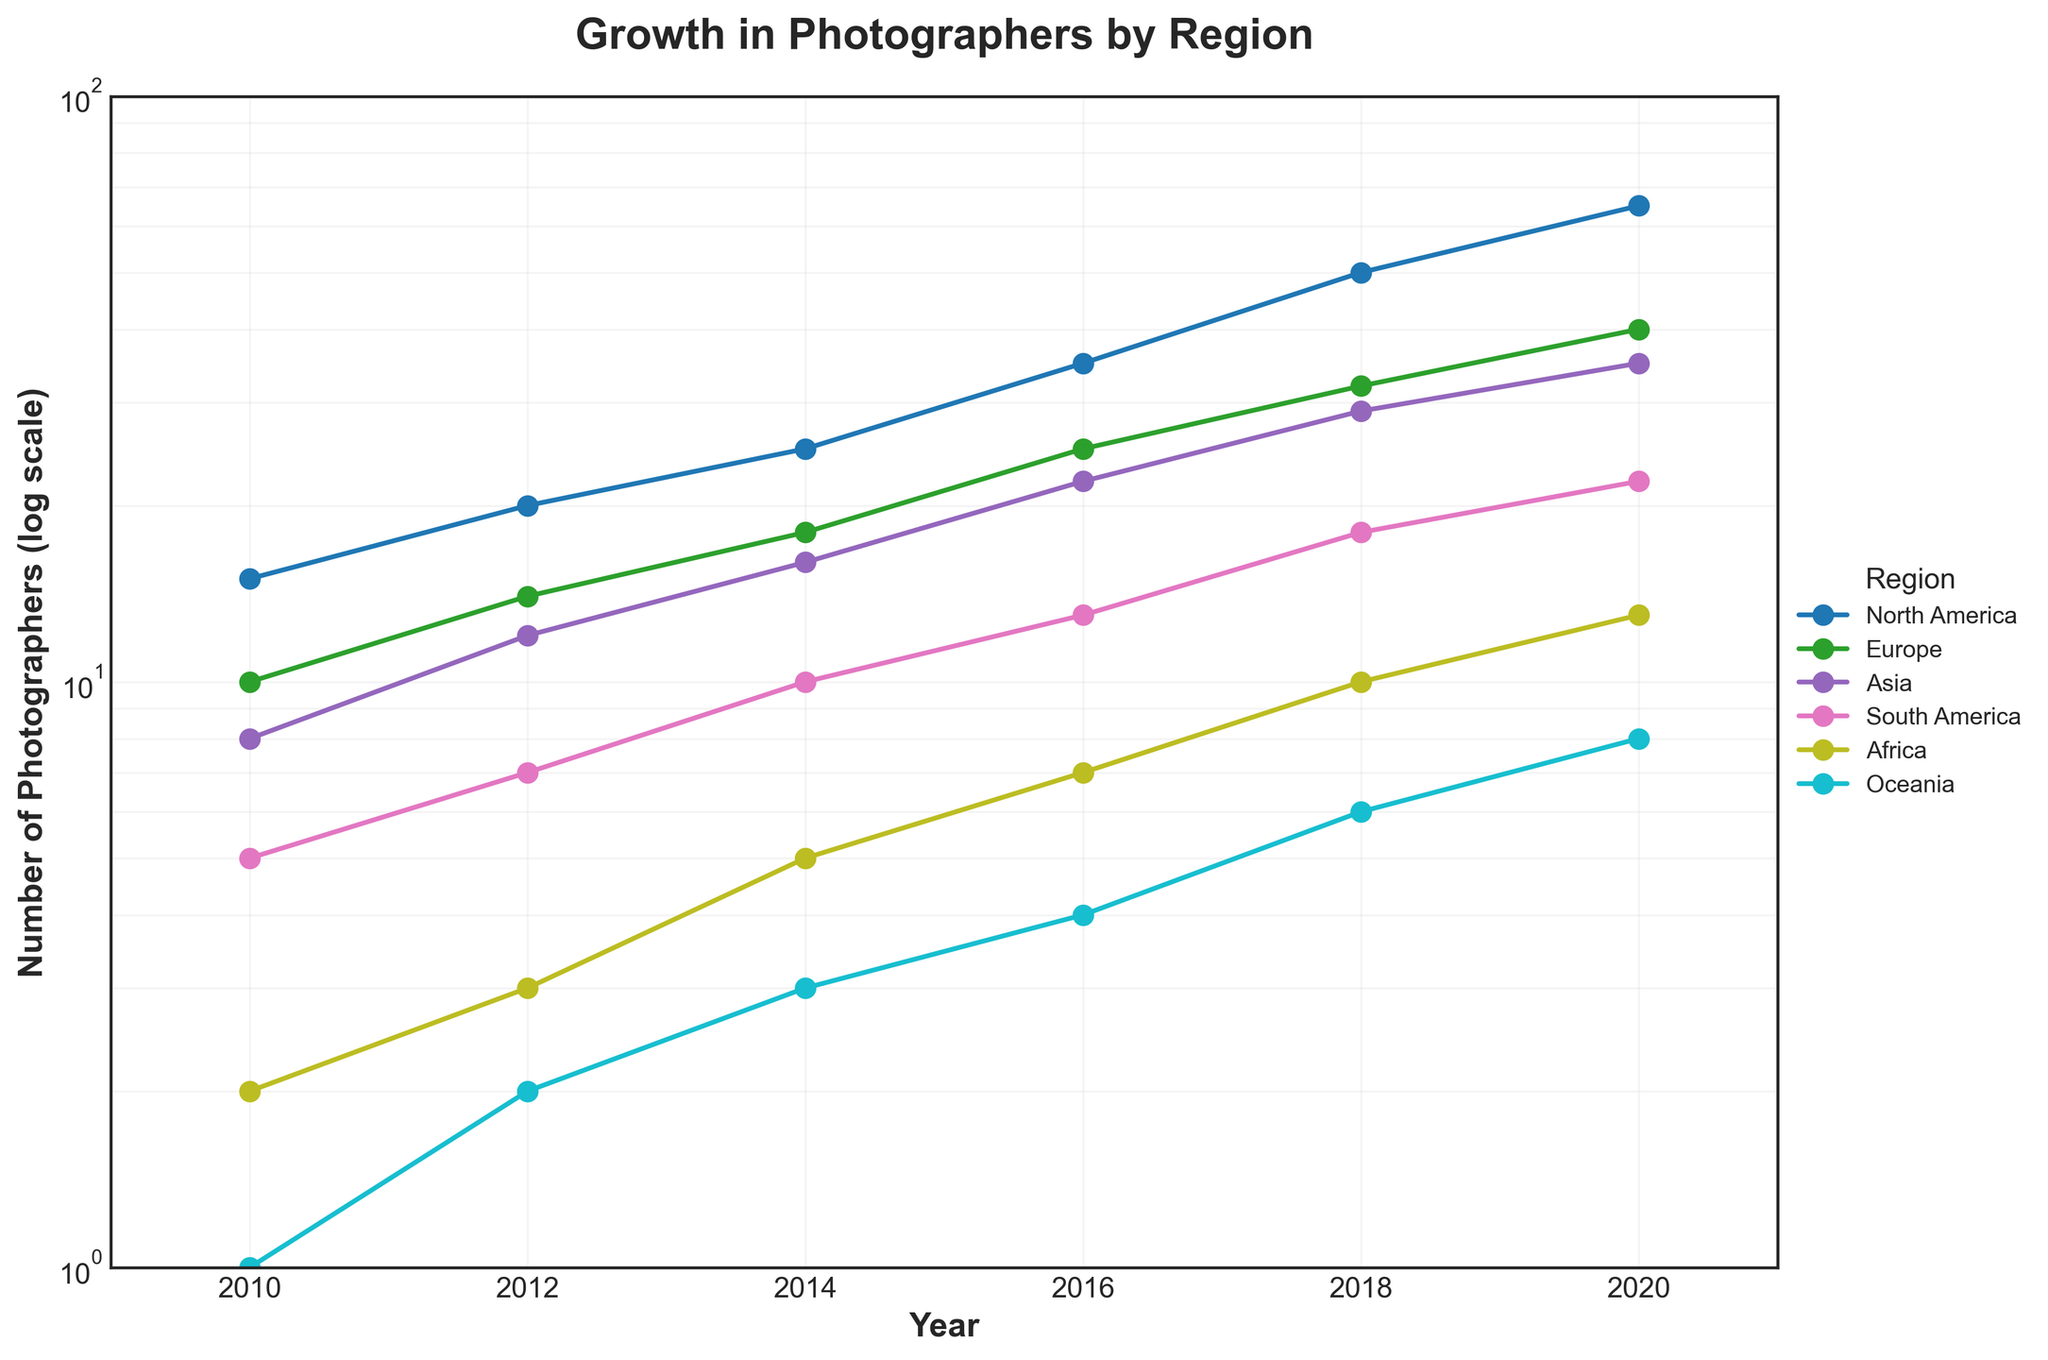What is the title of the figure? The title of the figure is usually at the top and is designed to give an overall idea of what the graph represents. In this case, it is "Growth in Photographers by Region".
Answer: Growth in Photographers by Region Which region had the highest number of photographers in 2020? Looking at the year 2020 on the x-axis, observe which region has the highest point on the y-axis. North America is at the topmost position.
Answer: North America How many photographers contributed from Oceania in 2016? Find the data point corresponding to the year 2016 on the x-axis and track it to the line representing Oceania (color coded). The associated y-axis value they intersect corresponds to 4.
Answer: 4 By what factor did the number of photographers from Africa increase from 2010 to 2020? Locate the data points for Africa in 2010 and 2020. In 2010, it is 2 and in 2020, it is 13. The factor increase is calculated by dividing 13 by 2.
Answer: 6.5 Which year saw the largest increase in photographers for Europe? Compare the increments between consecutive years for Europe by examining the slope of the line segments. The steepest slope is observed from 2016 to 2018.
Answer: 2018 On a logarithmic scale, which region's growth appears more linear over the 10 years? Examine the lines for each region. The more linear line on a log scale indicates exponential growth, which appears to be true for North America.
Answer: North America In 2014, which two regions had the same number of photographers? Look at the data points for each region in 2014 and compare the y-values. Asia and South America had the same number of photographers, which is 10.
Answer: Asia and South America Compare the number of photographers in North America and Asia in 2018. Which is higher and by how much? Check the data points for North America and Asia in 2018. North America has 50, and Asia has 29 photographers. The difference is 50 - 29.
Answer: North America, 21 On the log scale, why is it important to note the intervals on the y-axis? Log scales show exponential growth, and equal distances on the y-axis represent multiplicative growth. This compresses large ranges into manageable visual space.
Answer: Exponential representation Is the growth trend of photographers from South America increasing exponentially or linearly? Examine the line representing South America. If it is straight on the log scale, the growth is exponential; the slope is gentle but still consistent which indicates exponential rather than linear growth.
Answer: Exponentially 